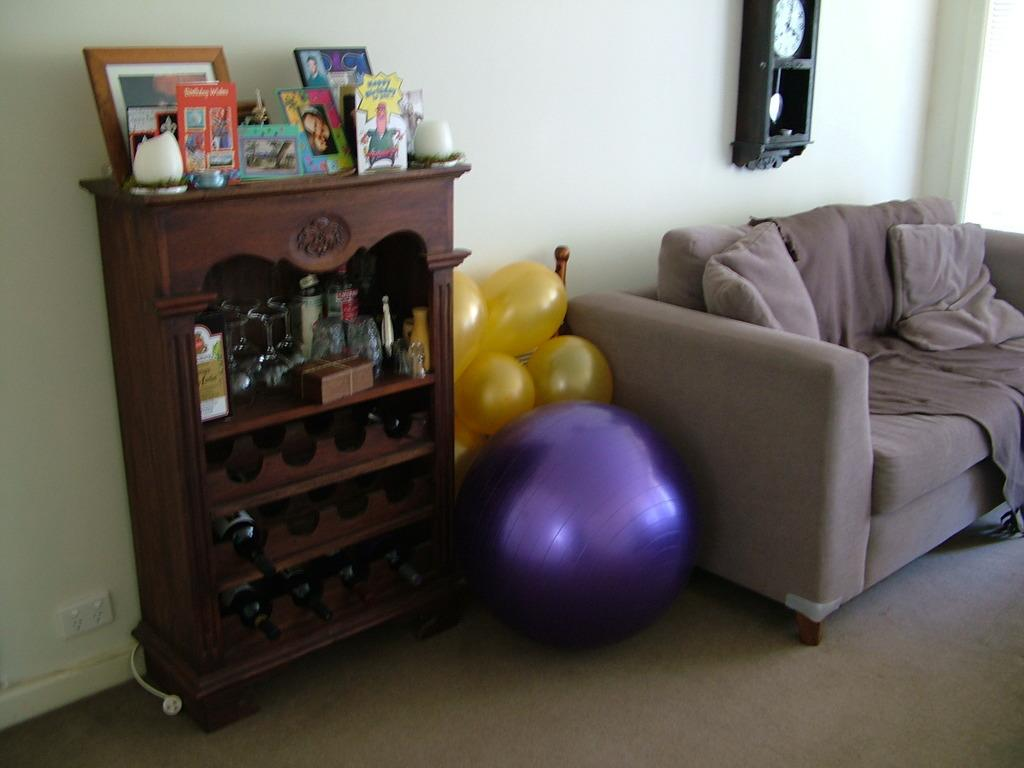Where was the image taken? The image was taken inside a room. What furniture is located on the right side of the room? There is a sofa on the right side of the room. What can be seen in the middle of the room? There are balloons in the middle of the room. What is on the left side of the room? There is a rack on the left side of the room. What is on the rack? The rack is full of frames and bottles, along with a few other things. What type of line can be seen connecting the balloons in the image? There is no line connecting the balloons in the image. Is there a fireman present in the image? No, there is no fireman present in the image. 